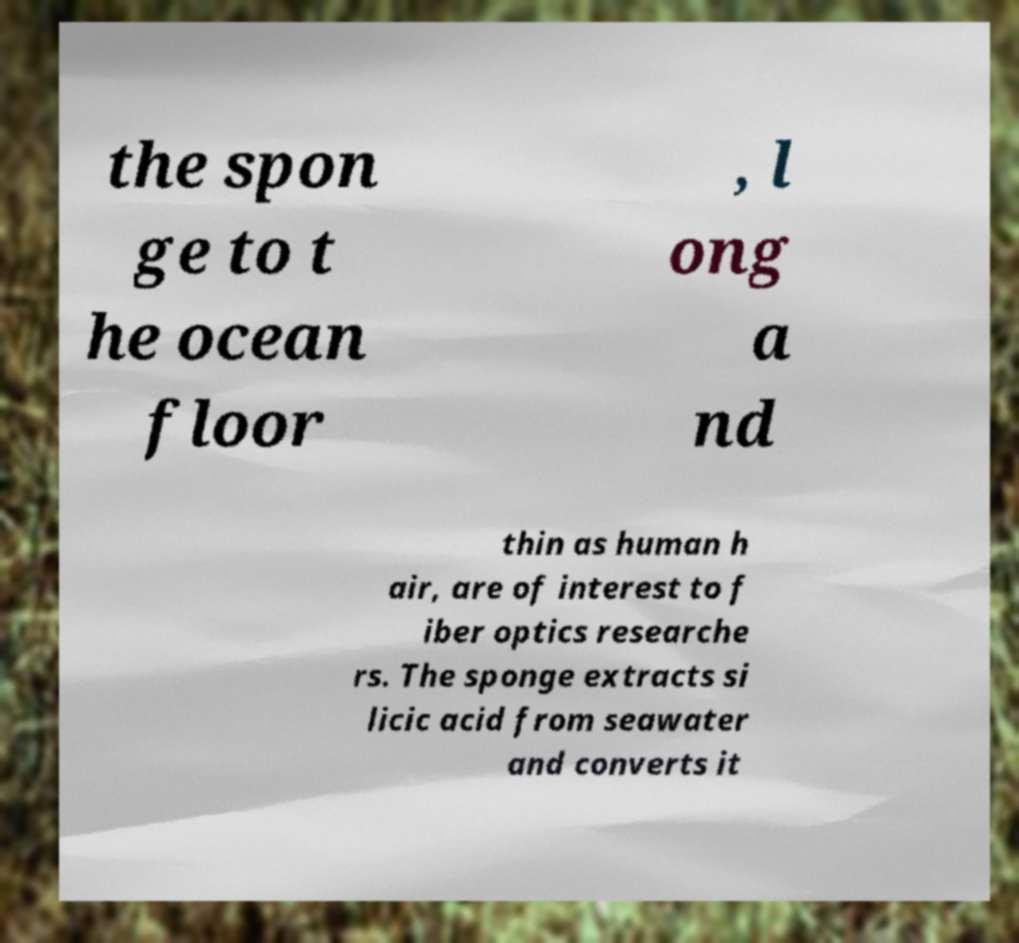Could you assist in decoding the text presented in this image and type it out clearly? the spon ge to t he ocean floor , l ong a nd thin as human h air, are of interest to f iber optics researche rs. The sponge extracts si licic acid from seawater and converts it 